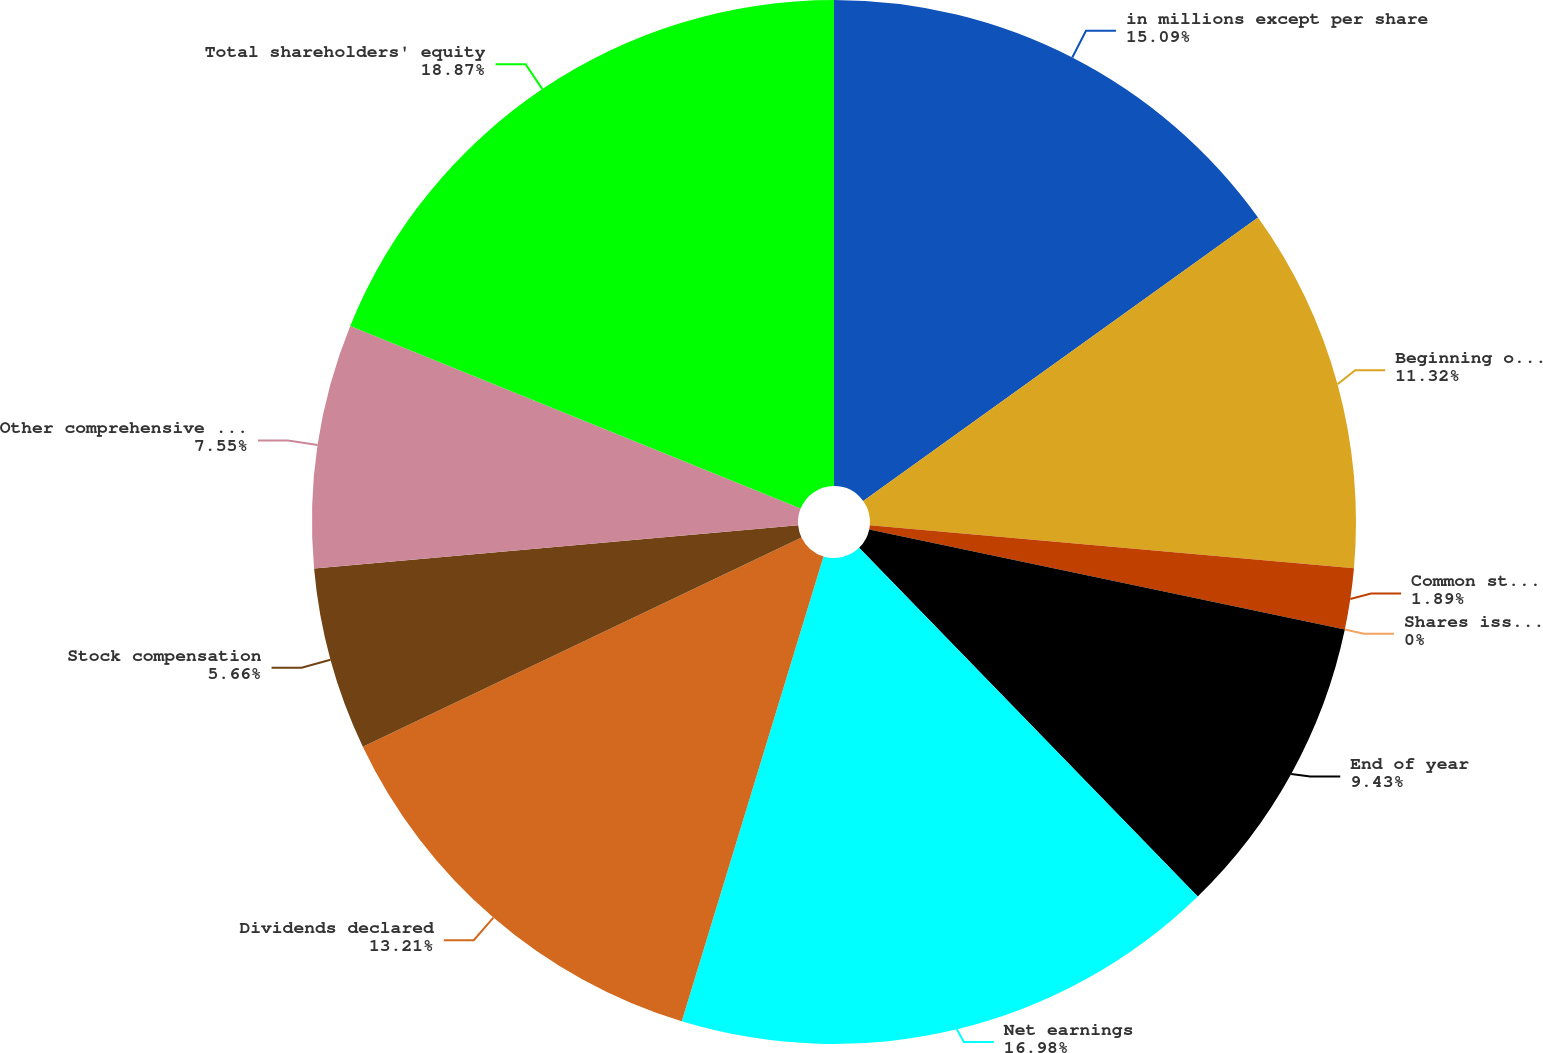Convert chart. <chart><loc_0><loc_0><loc_500><loc_500><pie_chart><fcel>in millions except per share<fcel>Beginning of year<fcel>Common stock repurchased<fcel>Shares issued for employee<fcel>End of year<fcel>Net earnings<fcel>Dividends declared<fcel>Stock compensation<fcel>Other comprehensive income<fcel>Total shareholders' equity<nl><fcel>15.09%<fcel>11.32%<fcel>1.89%<fcel>0.0%<fcel>9.43%<fcel>16.98%<fcel>13.21%<fcel>5.66%<fcel>7.55%<fcel>18.87%<nl></chart> 